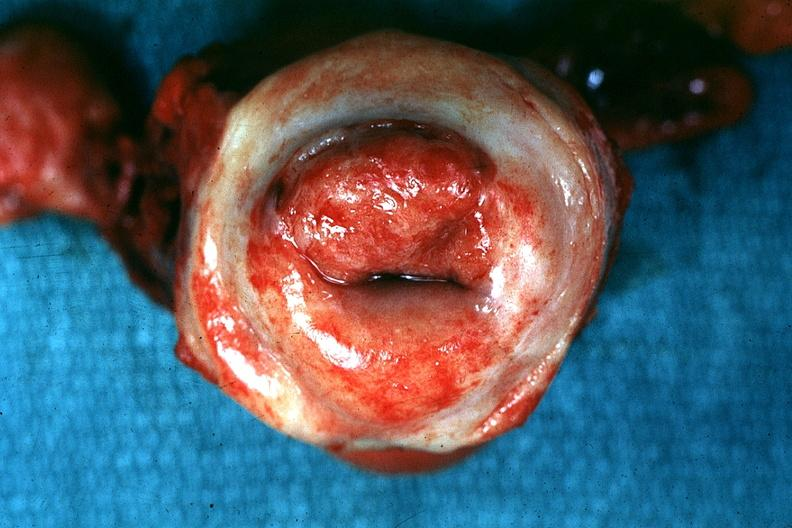s cervical carcinoma present?
Answer the question using a single word or phrase. Yes 